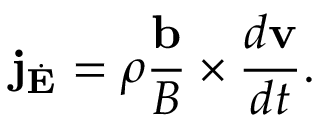Convert formula to latex. <formula><loc_0><loc_0><loc_500><loc_500>j _ { \dot { E } } = \rho \frac { b } { B } \times \frac { d v } { d t } .</formula> 